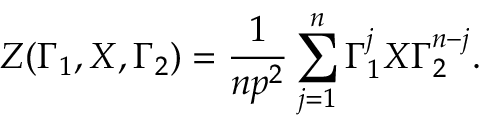<formula> <loc_0><loc_0><loc_500><loc_500>Z ( \Gamma _ { 1 } , X , \Gamma _ { 2 } ) = \frac { 1 } { n p ^ { 2 } } \sum _ { j = 1 } ^ { n } \Gamma _ { 1 } ^ { j } X \Gamma _ { 2 } ^ { n - j } .</formula> 